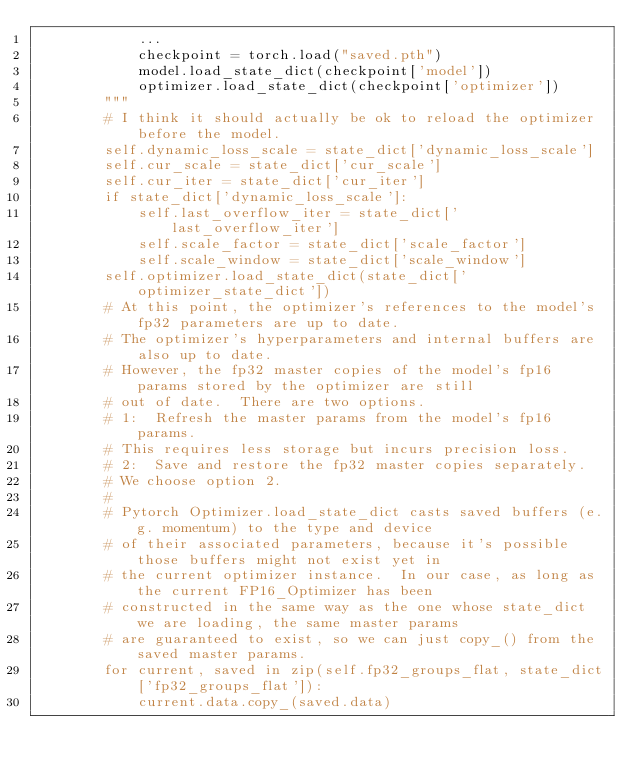<code> <loc_0><loc_0><loc_500><loc_500><_Python_>            ...
            checkpoint = torch.load("saved.pth")
            model.load_state_dict(checkpoint['model'])
            optimizer.load_state_dict(checkpoint['optimizer'])
        """
        # I think it should actually be ok to reload the optimizer before the model.
        self.dynamic_loss_scale = state_dict['dynamic_loss_scale']
        self.cur_scale = state_dict['cur_scale']
        self.cur_iter = state_dict['cur_iter']
        if state_dict['dynamic_loss_scale']:
            self.last_overflow_iter = state_dict['last_overflow_iter']
            self.scale_factor = state_dict['scale_factor']
            self.scale_window = state_dict['scale_window']
        self.optimizer.load_state_dict(state_dict['optimizer_state_dict'])
        # At this point, the optimizer's references to the model's fp32 parameters are up to date.
        # The optimizer's hyperparameters and internal buffers are also up to date.
        # However, the fp32 master copies of the model's fp16 params stored by the optimizer are still
        # out of date.  There are two options.
        # 1:  Refresh the master params from the model's fp16 params.
        # This requires less storage but incurs precision loss.
        # 2:  Save and restore the fp32 master copies separately.
        # We choose option 2.
        #
        # Pytorch Optimizer.load_state_dict casts saved buffers (e.g. momentum) to the type and device
        # of their associated parameters, because it's possible those buffers might not exist yet in
        # the current optimizer instance.  In our case, as long as the current FP16_Optimizer has been
        # constructed in the same way as the one whose state_dict we are loading, the same master params
        # are guaranteed to exist, so we can just copy_() from the saved master params.
        for current, saved in zip(self.fp32_groups_flat, state_dict['fp32_groups_flat']):
            current.data.copy_(saved.data)
</code> 